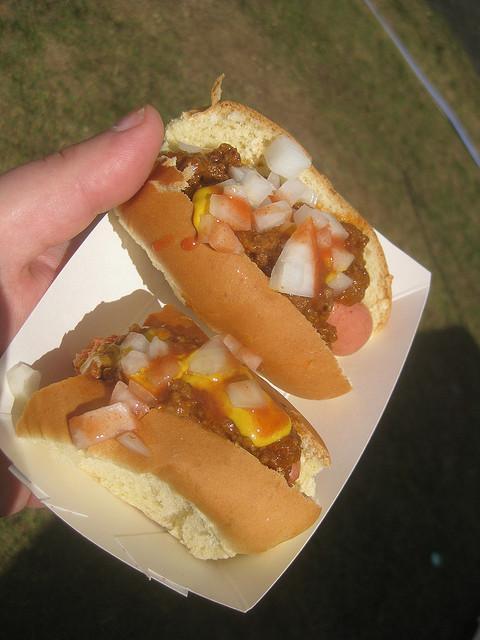How many hot dogs are there?
Give a very brief answer. 2. How many hot dogs are in the picture?
Give a very brief answer. 2. 